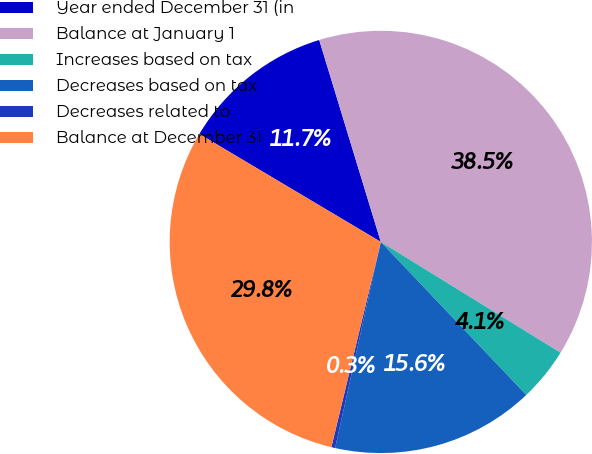Convert chart to OTSL. <chart><loc_0><loc_0><loc_500><loc_500><pie_chart><fcel>Year ended December 31 (in<fcel>Balance at January 1<fcel>Increases based on tax<fcel>Decreases based on tax<fcel>Decreases related to<fcel>Balance at December 31<nl><fcel>11.75%<fcel>38.51%<fcel>4.11%<fcel>15.57%<fcel>0.29%<fcel>29.78%<nl></chart> 